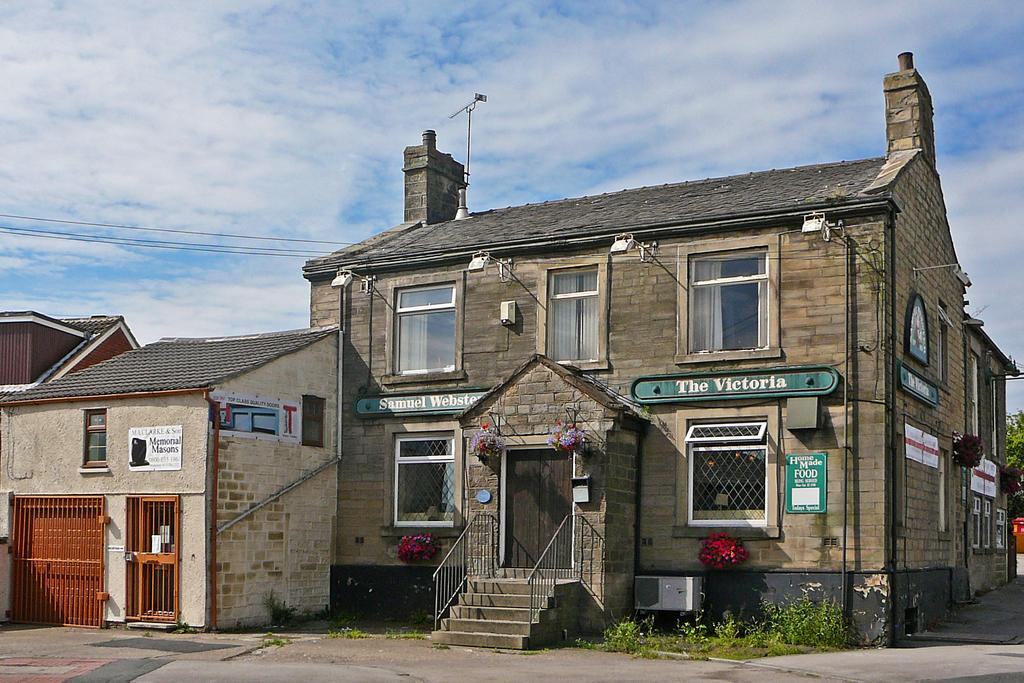What type of structure is present in the image? There is a building in the image. What architectural feature can be seen in the image? There are steps in the image. What can be seen on the building in the image? There are windows in the image. What type of natural environment is visible in the image? There is grass visible in the image. What is visible in the background of the image? The sky is visible in the background of the image. What fictional observation can be made about the building in the image? There is no fictional observation to be made about the building in the image; the facts provided are based on the actual elements visible in the image. 